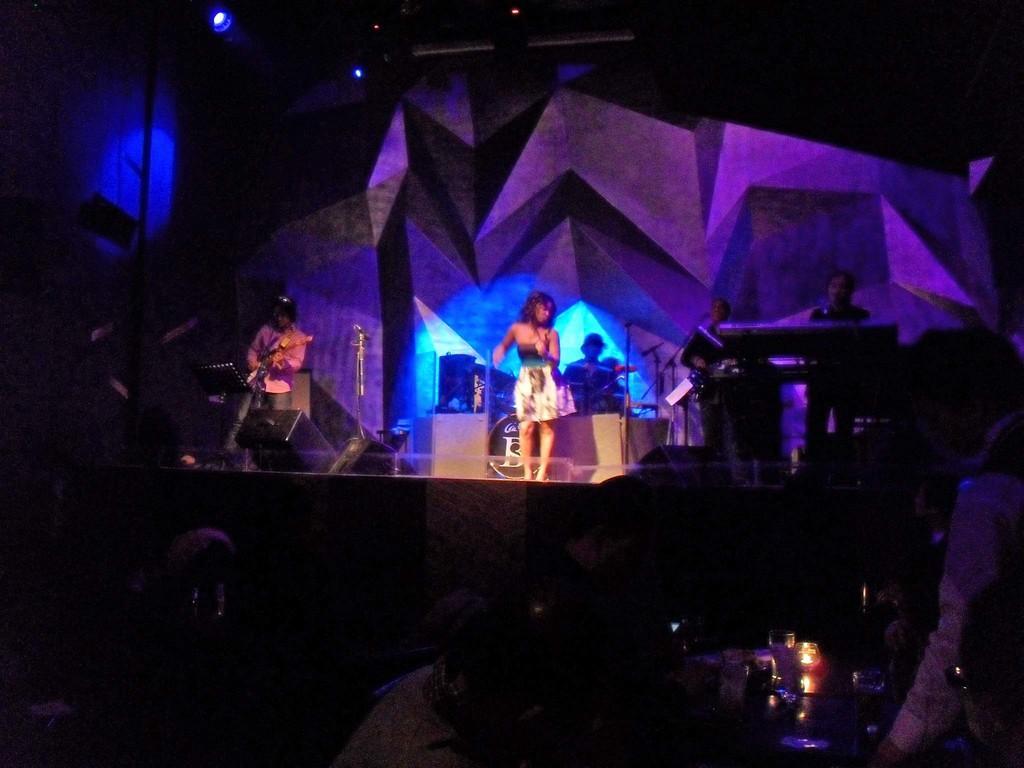Could you give a brief overview of what you see in this image? In this image I can see a person standing and the person is wearing white color dress, background I can see few persons playing some musical instruments and I can also see few lights. 